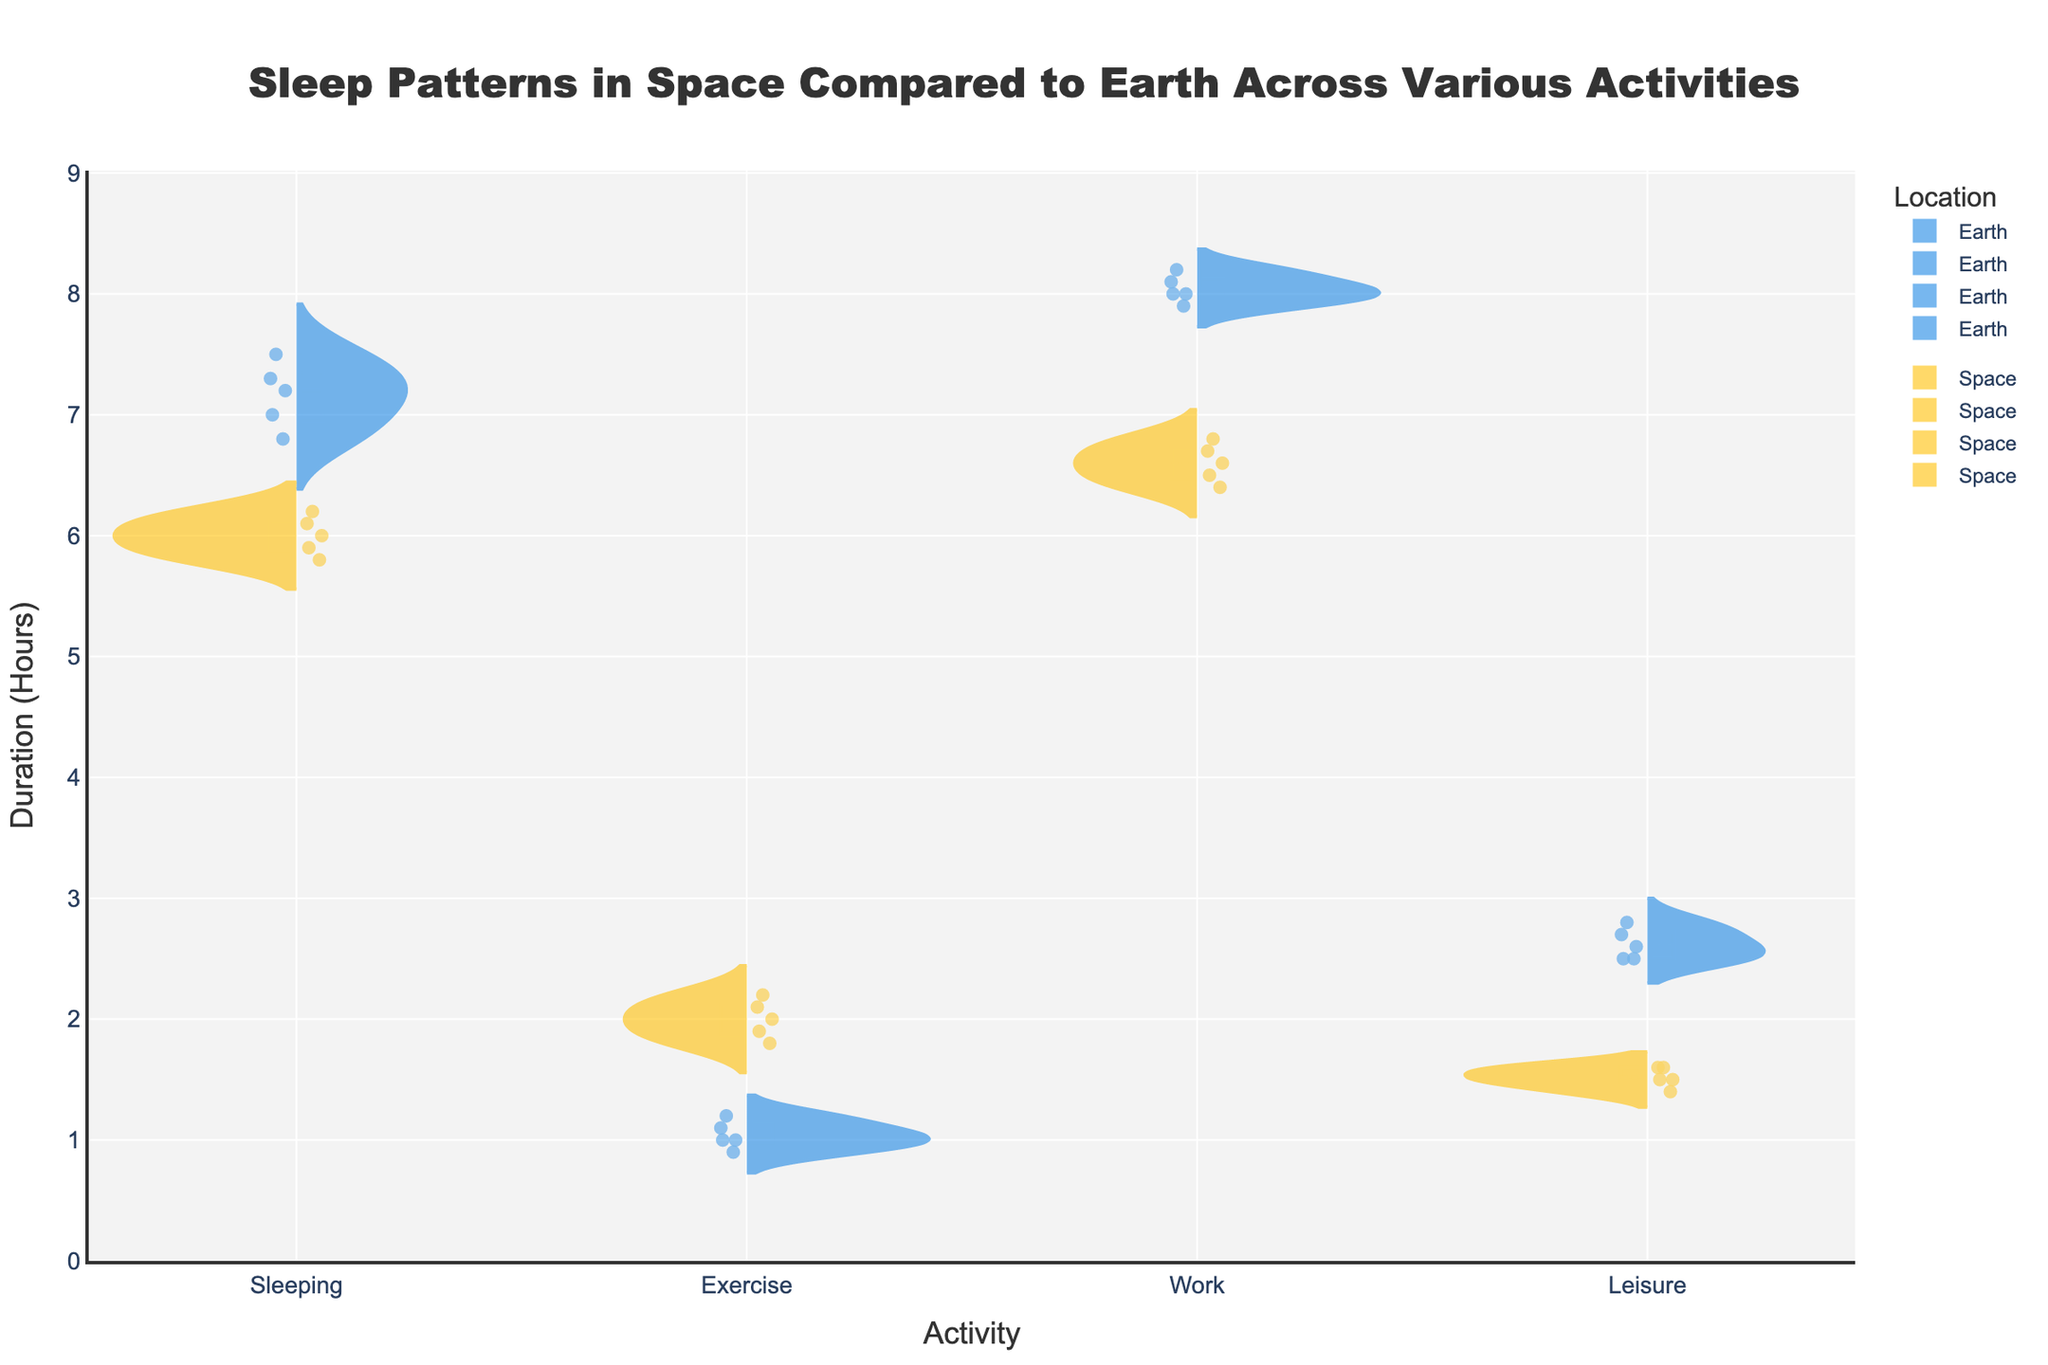What's the title of the figure? The title is displayed at the top of the figure.
Answer: Sleep Patterns in Space Compared to Earth Across Various Activities What activities are compared in the figure? The x-axis labels display the activities.
Answer: Sleeping, Exercise, Work, Leisure What is the y-axis representing in the figure? The y-axis title clearly states what it measures.
Answer: Duration (Hours) Which location has a higher median duration for Sleeping activity? The violin plot for Sleeping shows a thicker middle segment for Earth compared to Space.
Answer: Earth Which activity shows the largest difference in median duration between Earth and Space? By comparing the median lines of each activity, the largest gap appears between Earth and Space in the Exercise activity.
Answer: Exercise How many data points are there for each activity in Space? Each split violin plot shows the number of individual data points as small markers. Counting the markers for Space in each activity yields the answer.
Answer: 5 Which activity has the smallest duration range in Space? The width of the violin plot for each activity in Space can indicate the range. The plot for Leisure in Space is the narrowest.
Answer: Leisure What is the median duration for work activities on Earth? The median is represented by a line within the violin plot for the Work activity on Earth.
Answer: 8.0 hours Does the duration of Exercise activities generally increase or decrease in Space compared to Earth? By comparing the median lines and the distribution width of the split violin charts for Exercise, it appears that durations are generally higher in Space.
Answer: Increase What can you say about the distribution shape of Sleeping duration on Earth versus Space? The Sleeping duration on Earth is more uniformly distributed around the median while in Space it shows a more concentrated distribution with sharper peaks.
Answer: Earth: uniform, Space: concentrated 